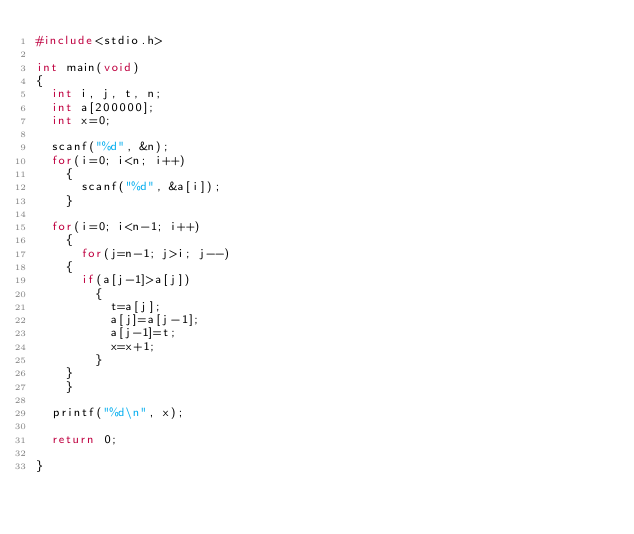<code> <loc_0><loc_0><loc_500><loc_500><_C_>#include<stdio.h>

int main(void)
{
  int i, j, t, n;
  int a[200000];
  int x=0;

  scanf("%d", &n);
  for(i=0; i<n; i++)
    {
      scanf("%d", &a[i]);
    }

  for(i=0; i<n-1; i++)
    {
      for(j=n-1; j>i; j--)
	{
	  if(a[j-1]>a[j])
	    {
	      t=a[j];
	      a[j]=a[j-1];
	      a[j-1]=t;
	      x=x+1;
	    }
	}
    }

  printf("%d\n", x);

  return 0;

}</code> 